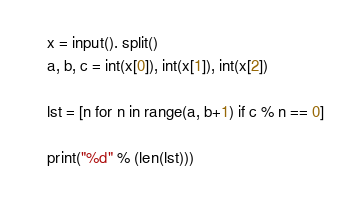Convert code to text. <code><loc_0><loc_0><loc_500><loc_500><_Python_>x = input(). split()
a, b, c = int(x[0]), int(x[1]), int(x[2])

lst = [n for n in range(a, b+1) if c % n == 0]

print("%d" % (len(lst)))
</code> 